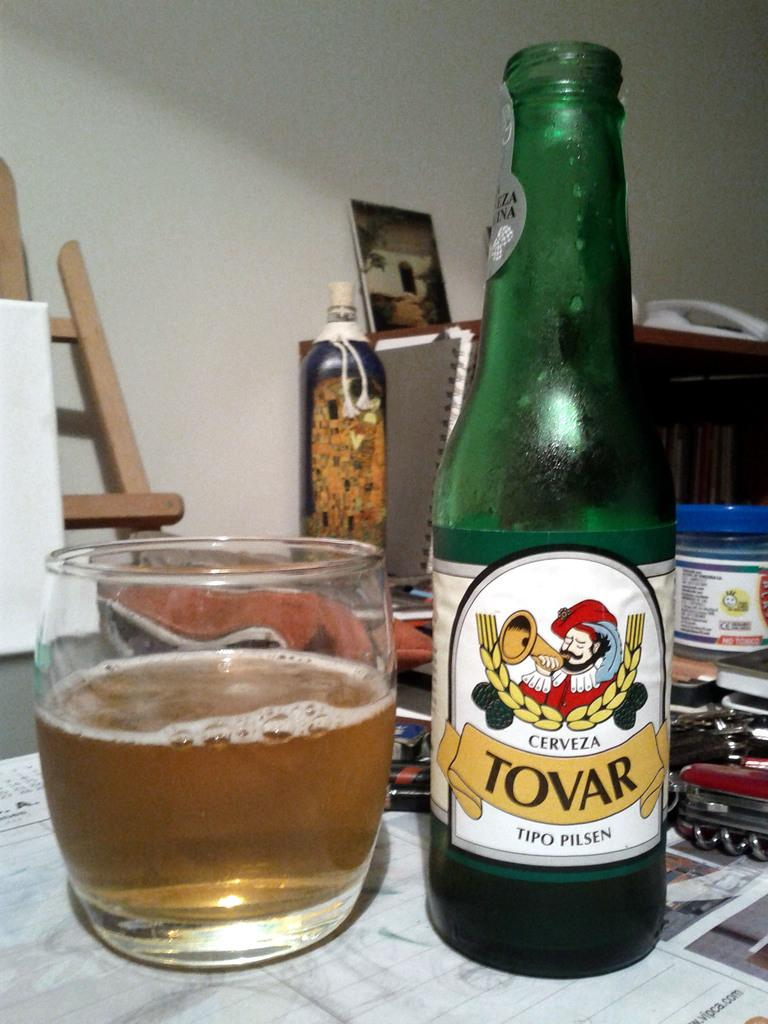<image>
Offer a succinct explanation of the picture presented. A bottle of Cerveza Toval Tipo Pilsen is next to a glass. 